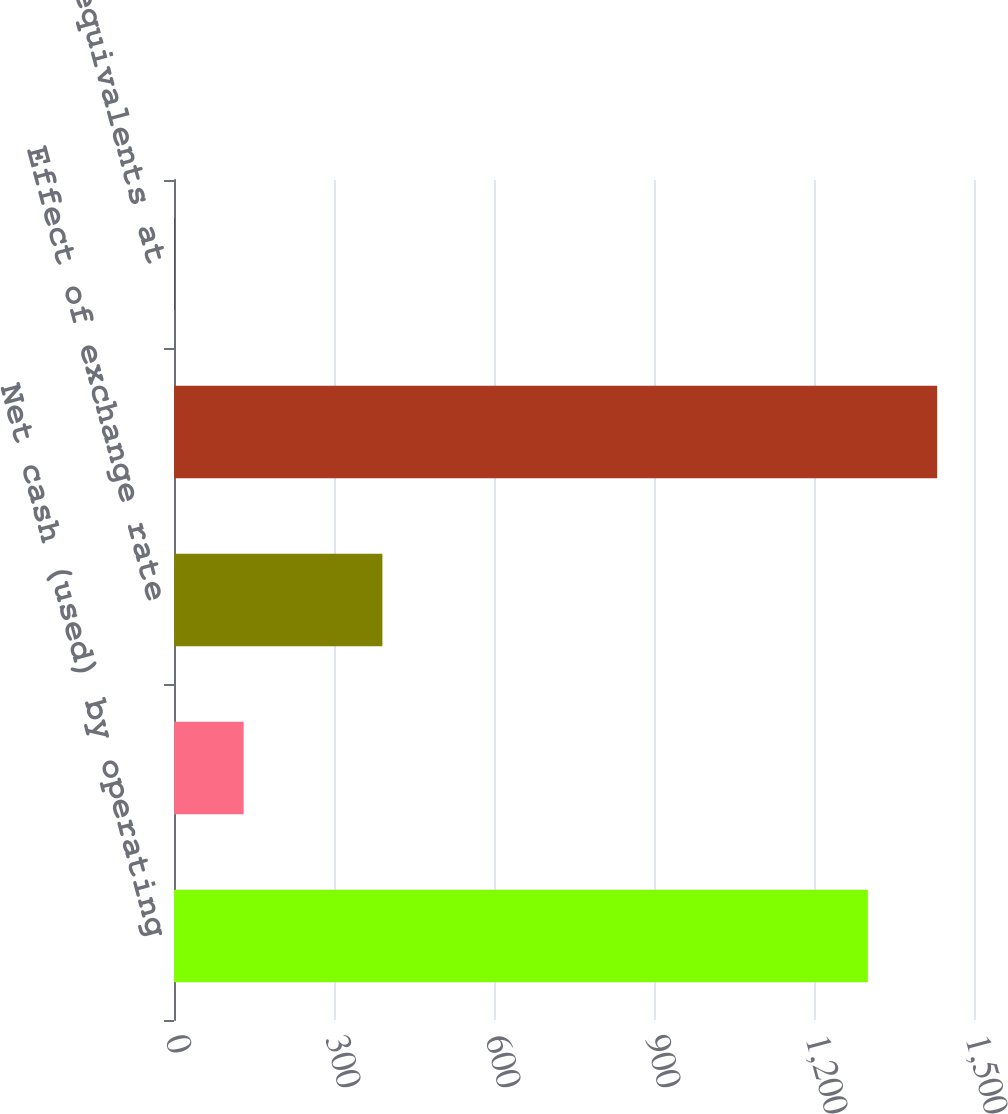<chart> <loc_0><loc_0><loc_500><loc_500><bar_chart><fcel>Net cash (used) by operating<fcel>Net cash provided by (used in)<fcel>Effect of exchange rate<fcel>Net decrease in cash and cash<fcel>Cash and cash equivalents at<nl><fcel>1301<fcel>130.59<fcel>390.69<fcel>1431.05<fcel>0.54<nl></chart> 